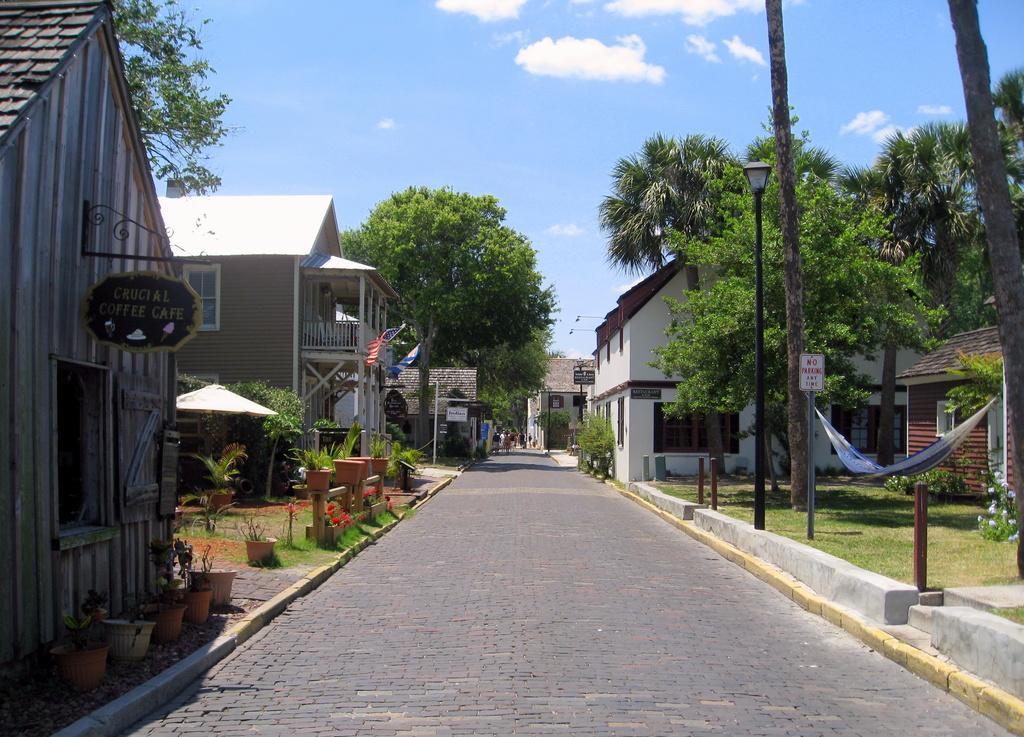How would you summarize this image in a sentence or two? In the middle of the image there is a road. On the left side of the image there buildings with walls, roofs, windows, balcony and also there is a name board. And on the footpath there are pots. In the middle of the buildings there is an umbrella and a tree. On the right side of the image there are trees, poles with sign boards and lamps, plants and grass and on the ground. In the background there are trees and few buildings. At the top of the image there is a sky with clouds. 